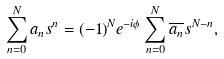<formula> <loc_0><loc_0><loc_500><loc_500>\sum _ { n = 0 } ^ { N } a _ { n } s ^ { n } = ( - 1 ) ^ { N } e ^ { - i \phi } \sum _ { n = 0 } ^ { N } \overline { a _ { n } } s ^ { N - n } ,</formula> 